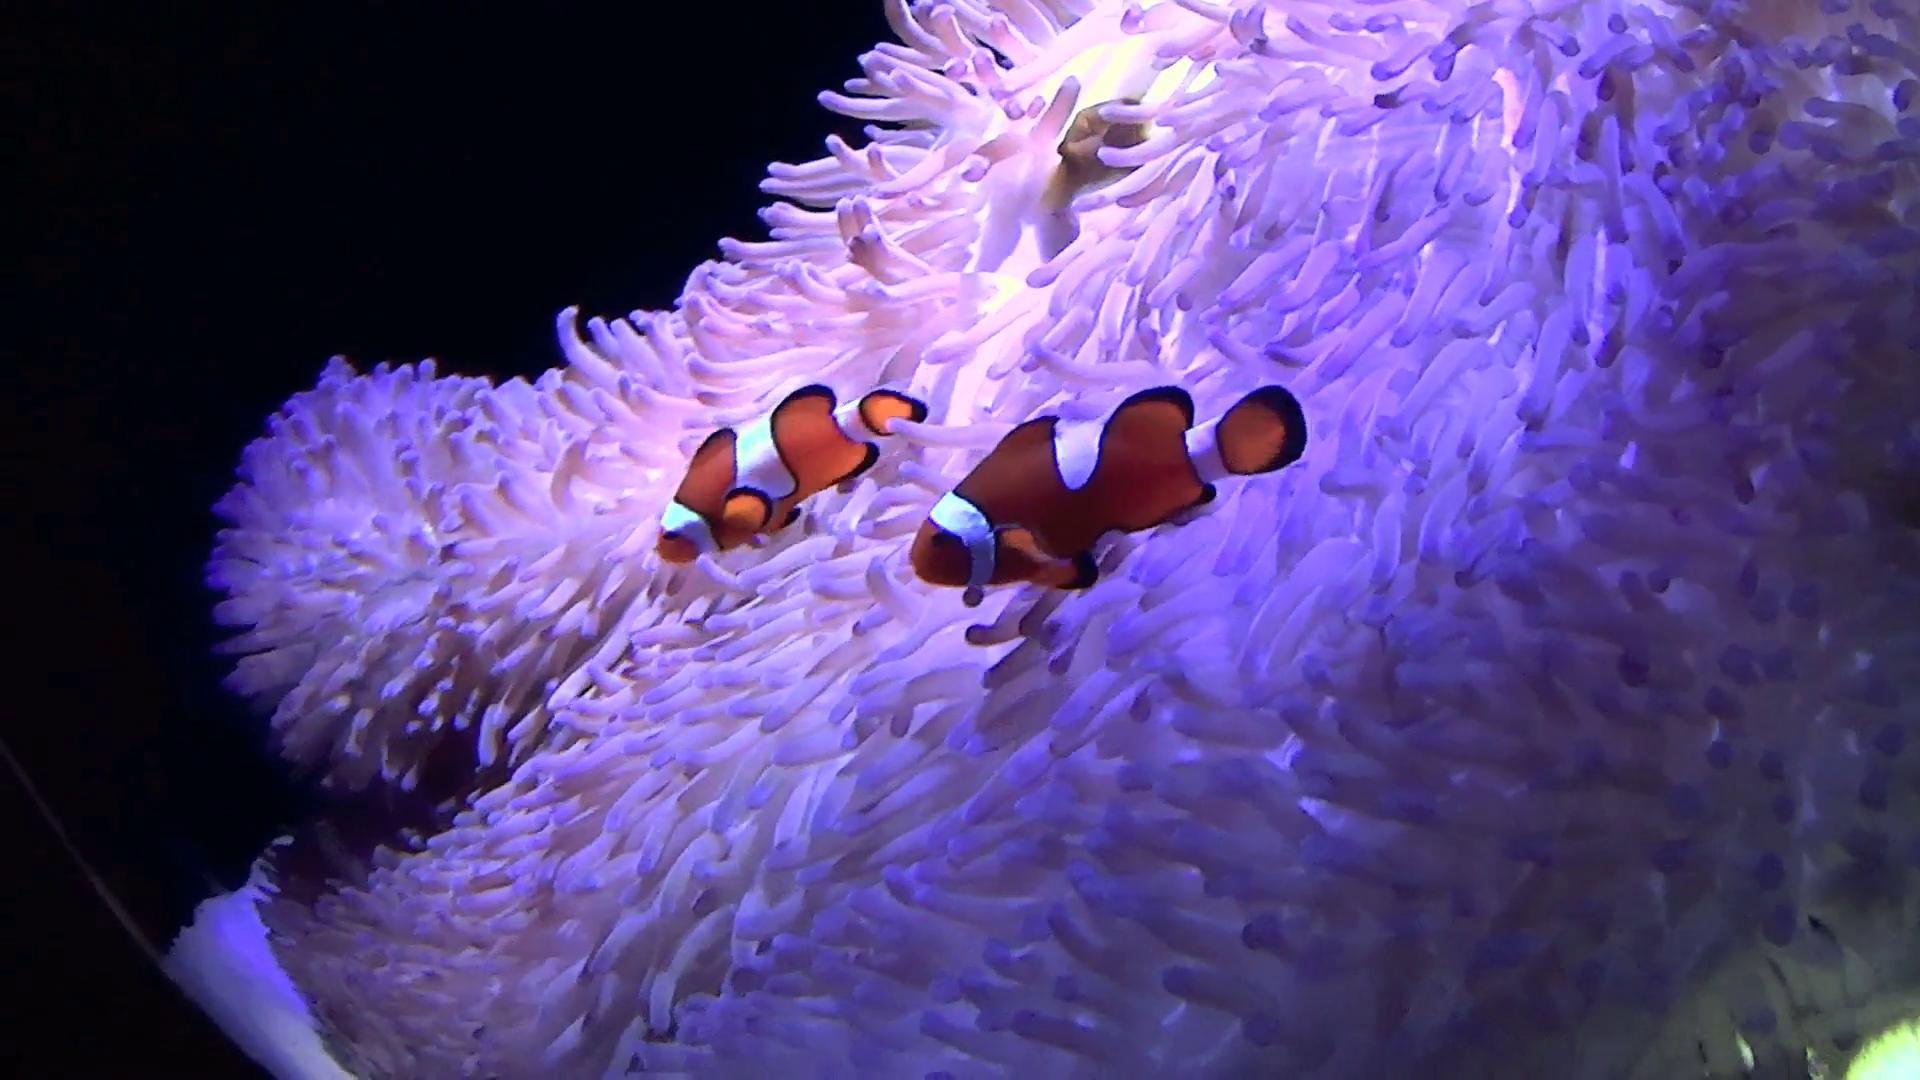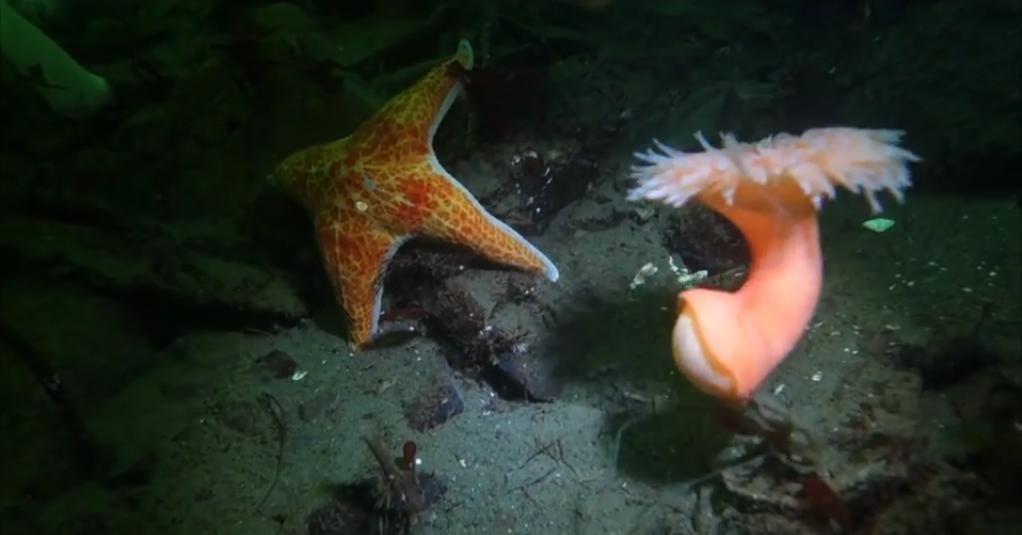The first image is the image on the left, the second image is the image on the right. Considering the images on both sides, is "One of the two images shows more than one of the same species of free-swimming fish." valid? Answer yes or no. Yes. The first image is the image on the left, the second image is the image on the right. Examine the images to the left and right. Is the description "At least one image shows fish swimming around a sea anemone." accurate? Answer yes or no. Yes. 